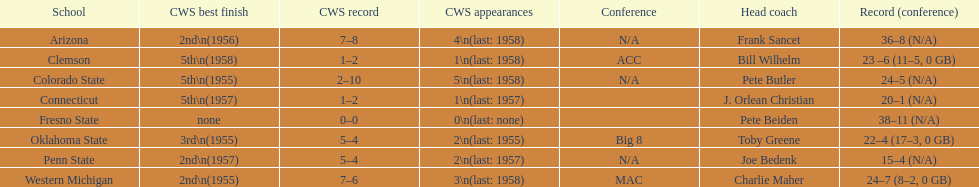Identify the schools that achieved the lowest position in the cws best outcome. Clemson, Colorado State, Connecticut. 